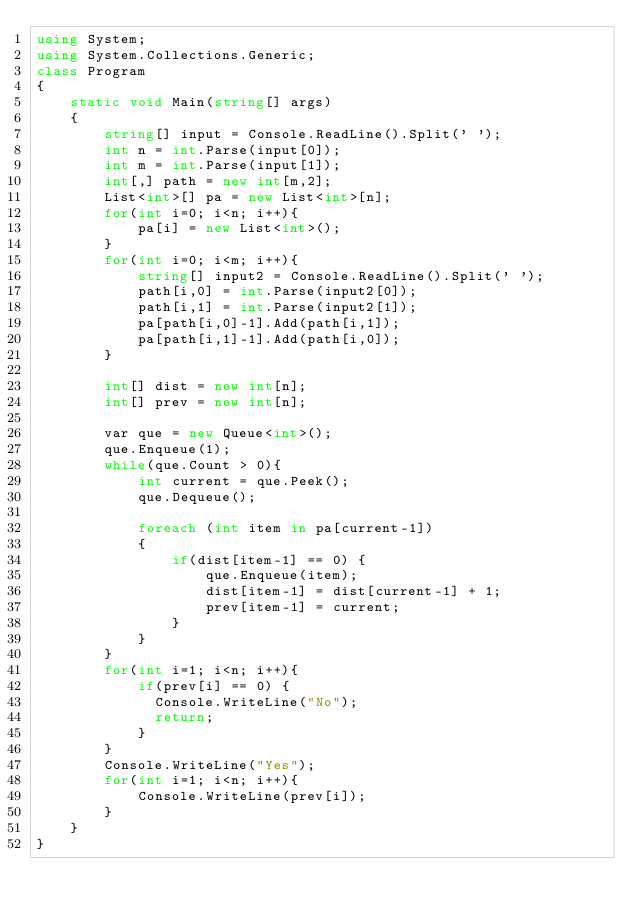Convert code to text. <code><loc_0><loc_0><loc_500><loc_500><_C#_>using System;
using System.Collections.Generic;
class Program
{
	static void Main(string[] args)
	{
        string[] input = Console.ReadLine().Split(' ');
        int n = int.Parse(input[0]);
        int m = int.Parse(input[1]);
        int[,] path = new int[m,2];
        List<int>[] pa = new List<int>[n];
        for(int i=0; i<n; i++){
          	pa[i] = new List<int>();
        }
        for(int i=0; i<m; i++){
            string[] input2 = Console.ReadLine().Split(' ');
            path[i,0] = int.Parse(input2[0]);
            path[i,1] = int.Parse(input2[1]);
            pa[path[i,0]-1].Add(path[i,1]);
            pa[path[i,1]-1].Add(path[i,0]);
        }

        int[] dist = new int[n];
        int[] prev = new int[n];

        var que = new Queue<int>();
        que.Enqueue(1);
        while(que.Count > 0){
            int current = que.Peek();
            que.Dequeue();

            foreach (int item in pa[current-1])
            {
                if(dist[item-1] == 0) {
                    que.Enqueue(item);
                    dist[item-1] = dist[current-1] + 1;
                    prev[item-1] = current;
                }
            }
        }
        for(int i=1; i<n; i++){
            if(prev[i] == 0) {
              Console.WriteLine("No");
              return;
            }
        }
        Console.WriteLine("Yes");
        for(int i=1; i<n; i++){
            Console.WriteLine(prev[i]);
        }
	}   
}
</code> 